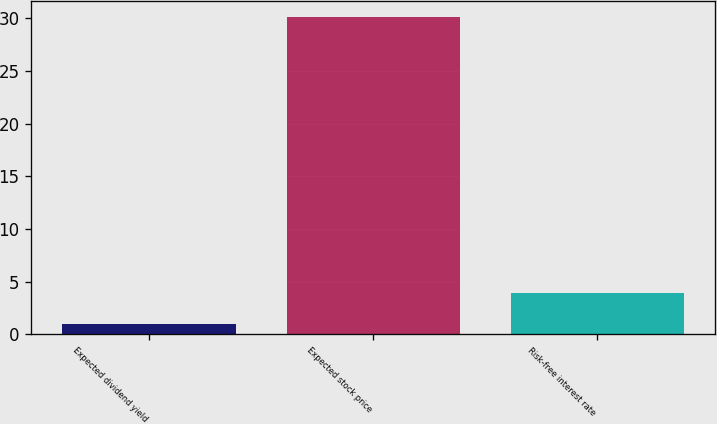Convert chart. <chart><loc_0><loc_0><loc_500><loc_500><bar_chart><fcel>Expected dividend yield<fcel>Expected stock price<fcel>Risk-free interest rate<nl><fcel>1.01<fcel>30.09<fcel>3.92<nl></chart> 